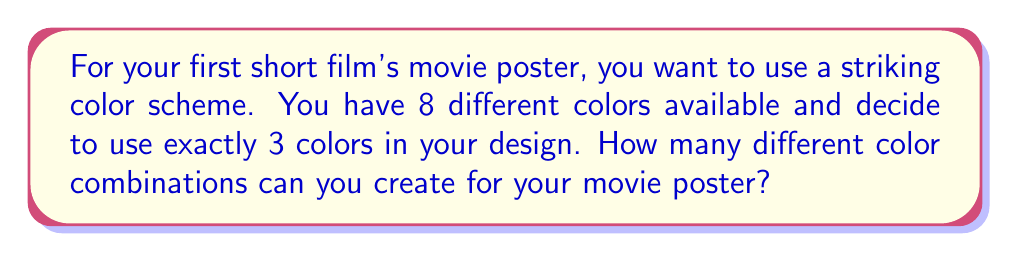Could you help me with this problem? Let's approach this step-by-step:

1) This is a combination problem. We are selecting 3 colors from a set of 8 colors, where the order doesn't matter (e.g., red-blue-green is the same combination as blue-green-red).

2) The formula for combinations is:

   $$C(n,r) = \frac{n!}{r!(n-r)!}$$

   Where $n$ is the total number of items to choose from, and $r$ is the number of items being chosen.

3) In this case, $n = 8$ (total colors available) and $r = 3$ (colors used in each design).

4) Plugging these values into our formula:

   $$C(8,3) = \frac{8!}{3!(8-3)!} = \frac{8!}{3!5!}$$

5) Expand this:
   $$\frac{8 \cdot 7 \cdot 6 \cdot 5!}{(3 \cdot 2 \cdot 1) \cdot 5!}$$

6) The $5!$ cancels out in the numerator and denominator:

   $$\frac{8 \cdot 7 \cdot 6}{3 \cdot 2 \cdot 1} = \frac{336}{6} = 56$$

Therefore, you can create 56 different color combinations for your movie poster.
Answer: 56 